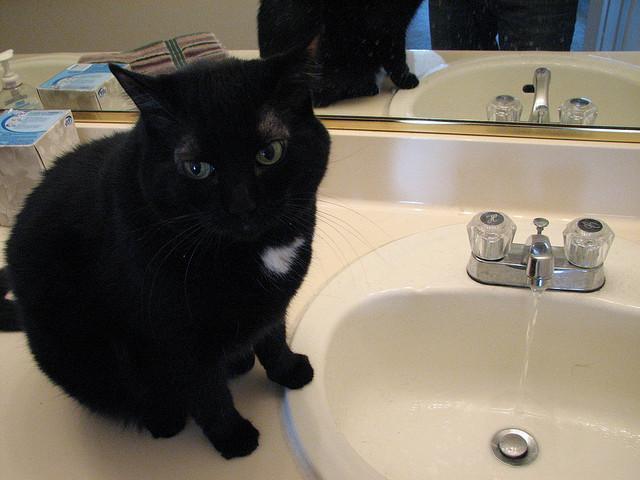How many cats are there?
Give a very brief answer. 2. How many people are wearing green shirts?
Give a very brief answer. 0. 